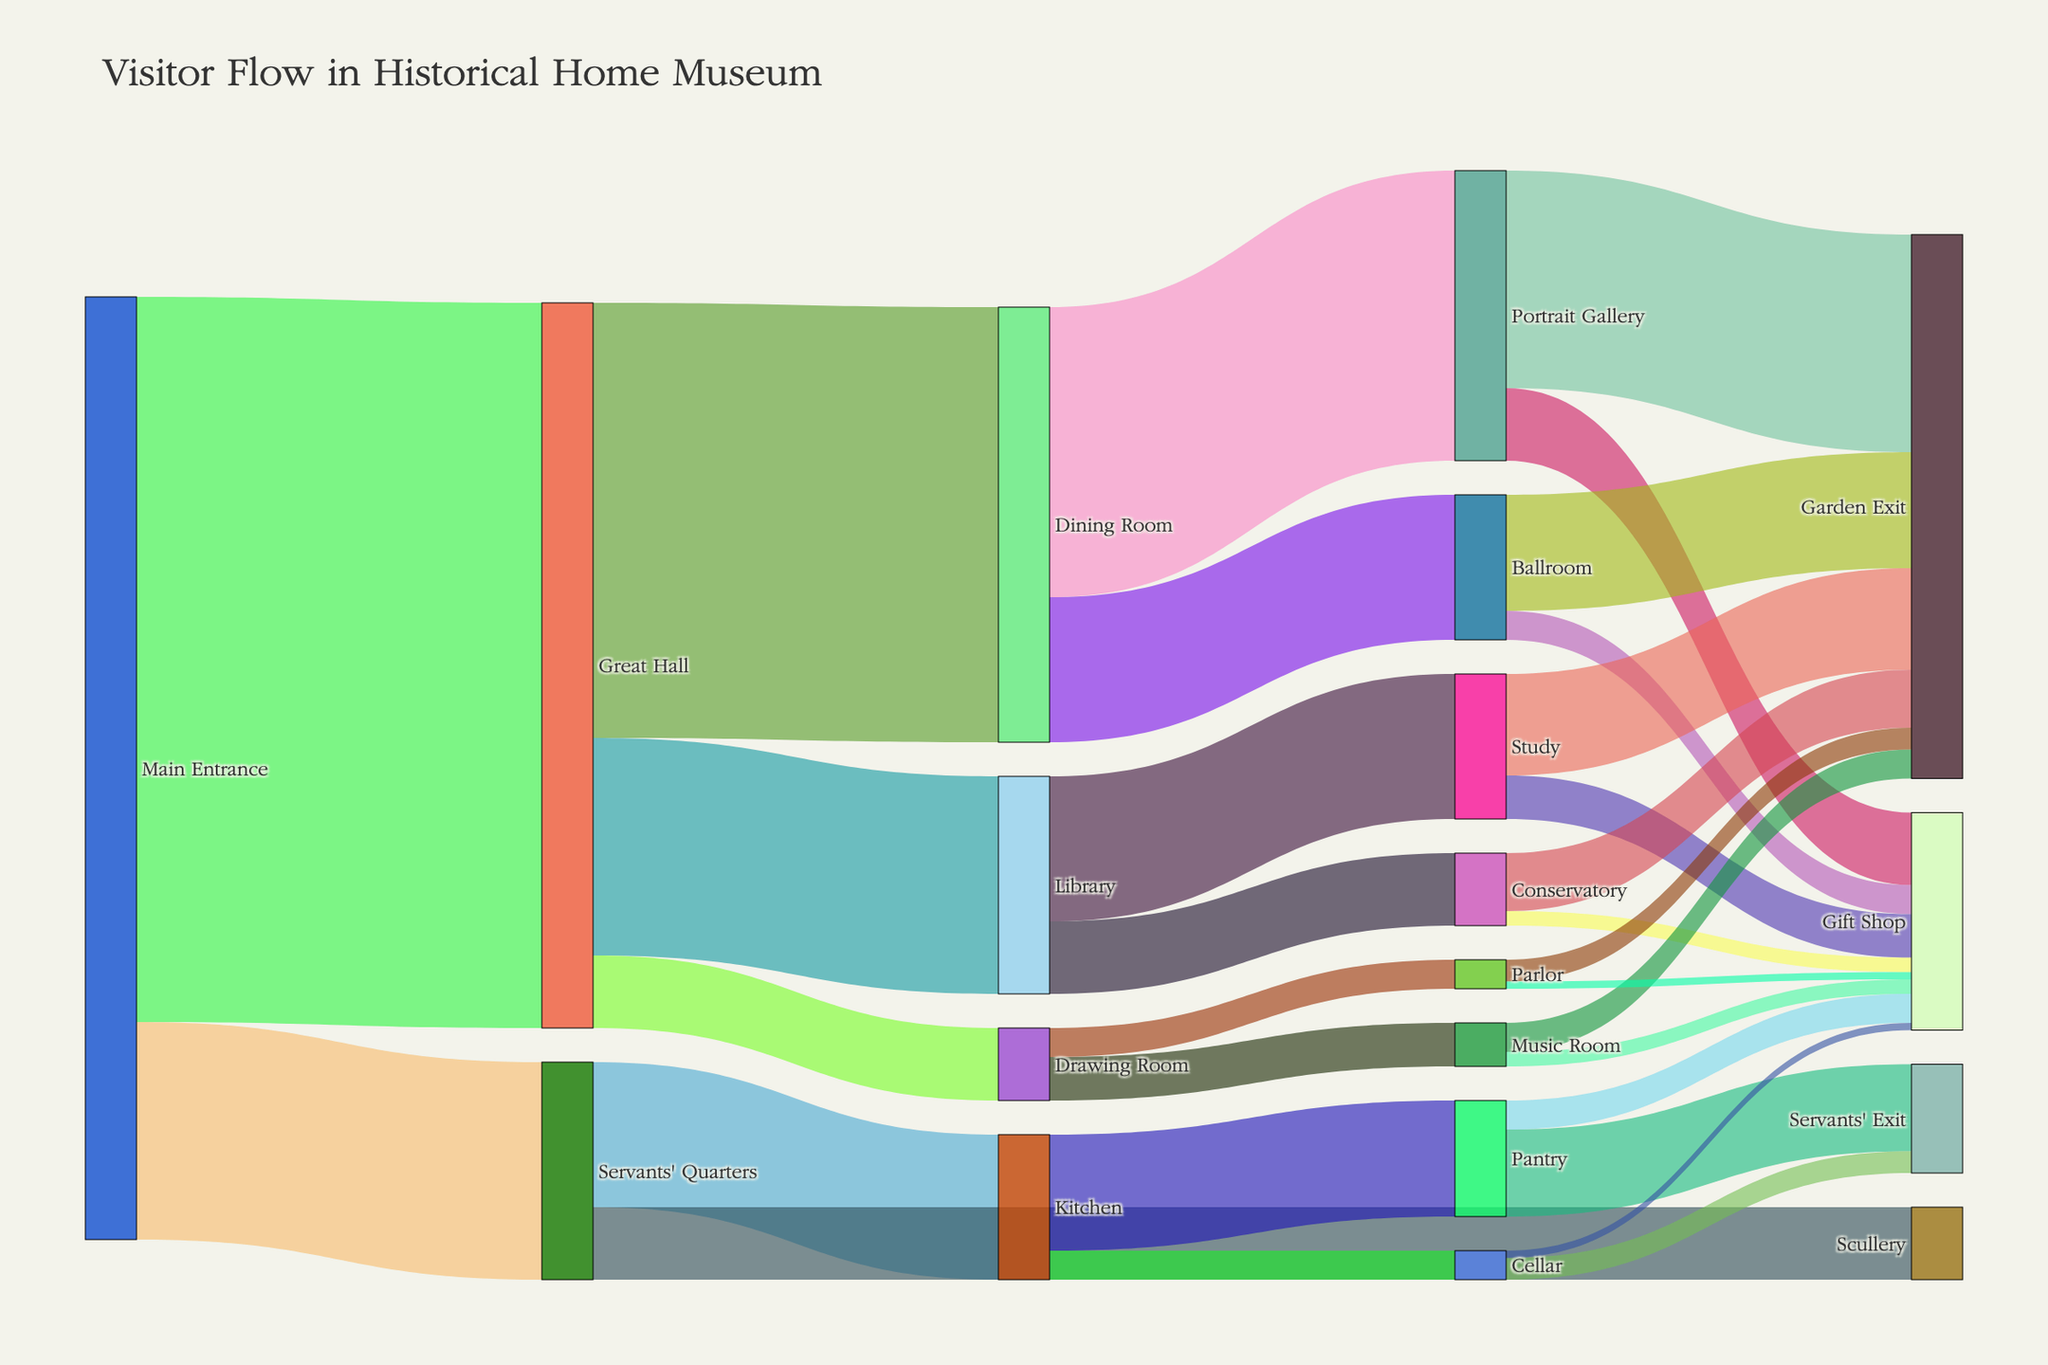what is the title of the figure? The title of the figure is located at the top of the Sankey Diagram.
Answer: Visitor Flow in Historical Home Museum what sections do visitors enter after the Great Hall? By looking at the connections from the Great Hall, we can see the paths leading to the Dining Room, Library, and Drawing Room.
Answer: Dining Room, Library, Drawing Room which section has the largest number of visitors coming from the Main Entrance? By examining the connections from the Main Entrance, we can see the numbers are 500, 150. 500 is the largest, corresponding to the Great Hall.
Answer: Great Hall which exit route has the most visitors? By examining the paths leading to exits (Garden Exit and Gift Shop), we see the highest values include 150 for Garden Exit (from Portrait Gallery).
Answer: Garden Exit from Portrait Gallery how many visitors go to the Gift Shop from all sections? We need to sum the values leading to Gift Shop: Portrait Gallery (50), Ballroom (20), Study (30), Conservatory (10), Music Room (10), Parlor (5), Pantry (20), Cellar (5). The total is 50 + 20 + 30 + 10 + 10 + 5 + 20 + 5 = 150.
Answer: 150 compare the number of visitors who move from the Great Hall to the Dining Room versus those who move from the Great Hall to the Library. We compare the paths from the Great Hall, where Dining Room has 300 visitors and Library has 150 visitors.
Answer: Dining Room has more visitors by 150 which sections do visitors exit from after visiting the Servants' Quarters? We look at the paths from the Servants' Quarters, leading to Kitchen and Scullery.
Answer: Kitchen, Scullery what is the combined number of visitors exiting through the Garden Exit from all sections? We sum the values for Garden Exit from all paths: Portrait Gallery (150), Ballroom (80), Study (70), Conservatory (40), Music Room (20), Parlor (15). Total is 150 + 80 + 70 + 40 + 20 + 15 = 375.
Answer: 375 compare the number of people who visited the Ballroom versus those who visited the Library. From the chart, we see that the Dining Room sends 100 visitors to the Ballroom and the Great Hall sends 150 visitors to the Library. 150 (Library) is greater than 100 (Ballroom).
Answer: Library has more visitors by 50 how does the visitor flow through the Pantry compare to the flow through the Cellar? We need to look at the flow from and out of these sections: Kitchen (80) to Pantry and Cellar (20), Pantry to Servants' Exit (60) and Gift Shop (20), Cellar to Servants' Exit (15) and Gift Shop (5). So the flow through the Pantry (80 + 60 + 20) is larger than through the Cellar (20 + 15 + 5).
Answer: Pantry has more flow 